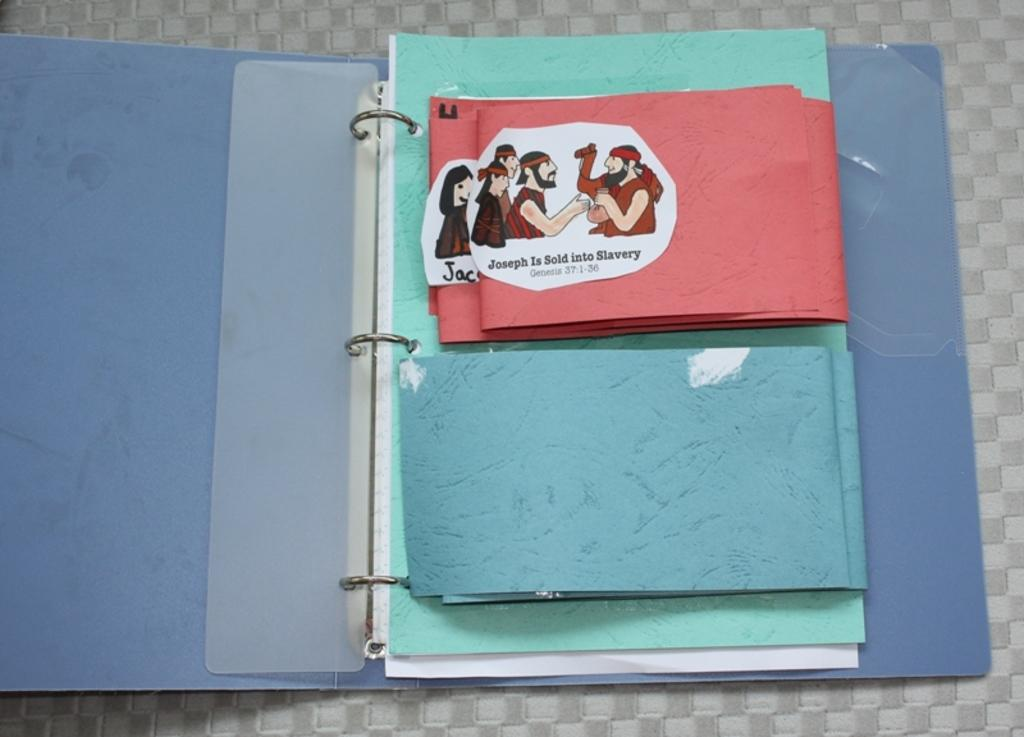What is the main object in the image? There is a file in the image. Where is the file located? The file is on a surface. What is the state of the file? The file is open. What can be found inside the file? There are papers in the file. What is depicted on the papers? The papers contain pictures of a person and a camel, as well as text. What type of advertisement can be seen on the house in the image? There is no house or advertisement present in the image. What flavor of jam is being spread on the toast in the image? There is no toast or jam present in the image. 